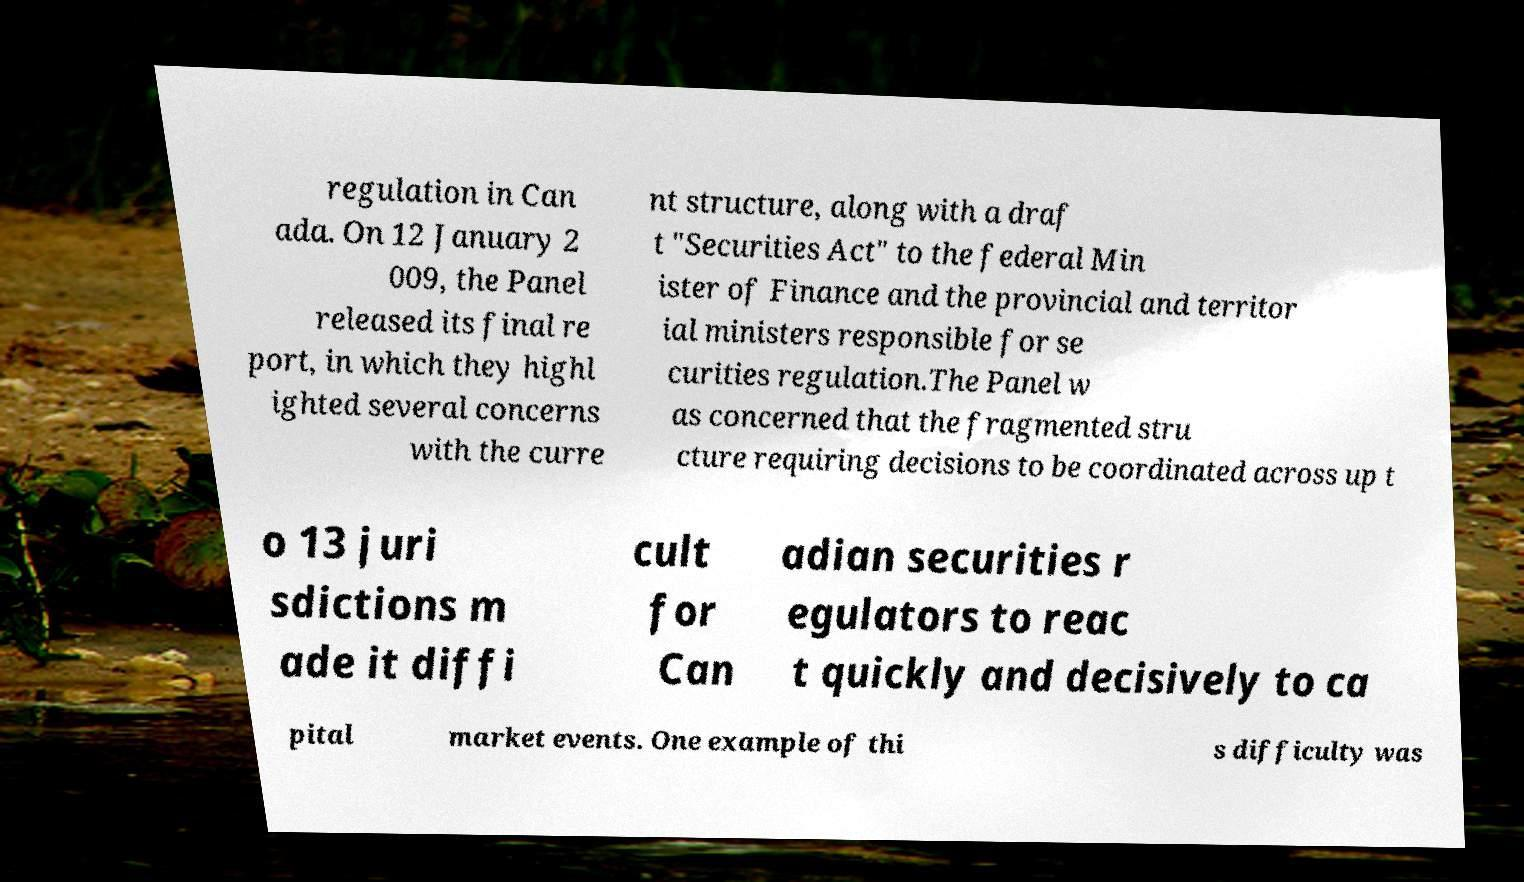Please identify and transcribe the text found in this image. regulation in Can ada. On 12 January 2 009, the Panel released its final re port, in which they highl ighted several concerns with the curre nt structure, along with a draf t "Securities Act" to the federal Min ister of Finance and the provincial and territor ial ministers responsible for se curities regulation.The Panel w as concerned that the fragmented stru cture requiring decisions to be coordinated across up t o 13 juri sdictions m ade it diffi cult for Can adian securities r egulators to reac t quickly and decisively to ca pital market events. One example of thi s difficulty was 